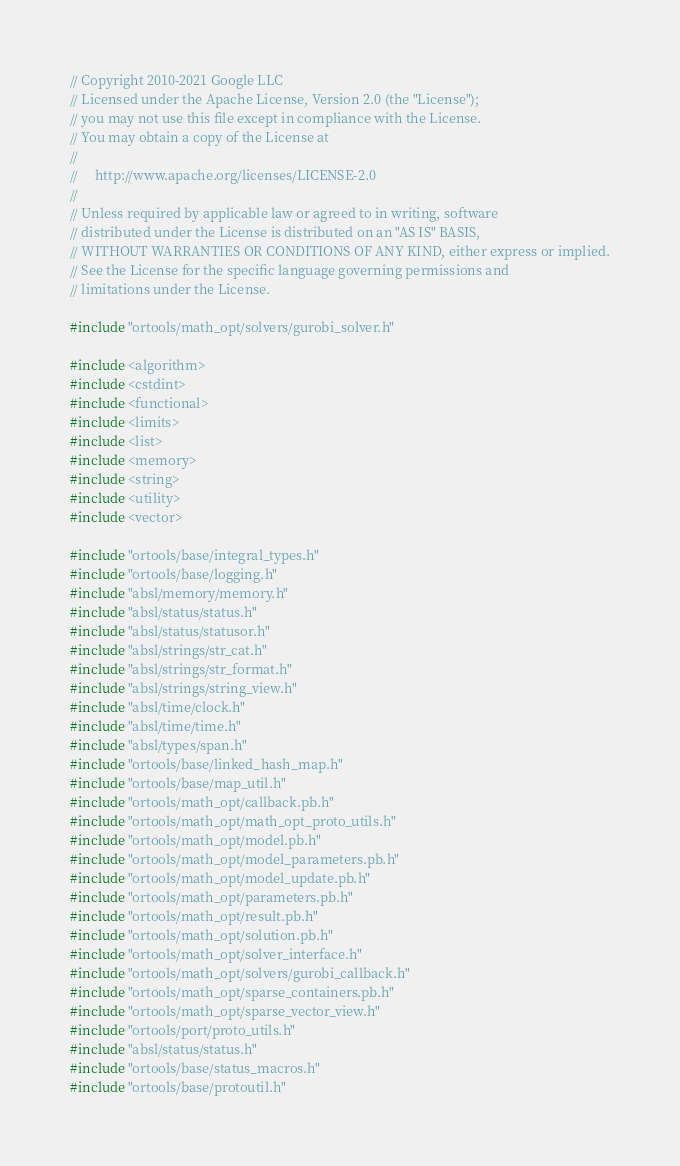Convert code to text. <code><loc_0><loc_0><loc_500><loc_500><_C++_>// Copyright 2010-2021 Google LLC
// Licensed under the Apache License, Version 2.0 (the "License");
// you may not use this file except in compliance with the License.
// You may obtain a copy of the License at
//
//     http://www.apache.org/licenses/LICENSE-2.0
//
// Unless required by applicable law or agreed to in writing, software
// distributed under the License is distributed on an "AS IS" BASIS,
// WITHOUT WARRANTIES OR CONDITIONS OF ANY KIND, either express or implied.
// See the License for the specific language governing permissions and
// limitations under the License.

#include "ortools/math_opt/solvers/gurobi_solver.h"

#include <algorithm>
#include <cstdint>
#include <functional>
#include <limits>
#include <list>
#include <memory>
#include <string>
#include <utility>
#include <vector>

#include "ortools/base/integral_types.h"
#include "ortools/base/logging.h"
#include "absl/memory/memory.h"
#include "absl/status/status.h"
#include "absl/status/statusor.h"
#include "absl/strings/str_cat.h"
#include "absl/strings/str_format.h"
#include "absl/strings/string_view.h"
#include "absl/time/clock.h"
#include "absl/time/time.h"
#include "absl/types/span.h"
#include "ortools/base/linked_hash_map.h"
#include "ortools/base/map_util.h"
#include "ortools/math_opt/callback.pb.h"
#include "ortools/math_opt/math_opt_proto_utils.h"
#include "ortools/math_opt/model.pb.h"
#include "ortools/math_opt/model_parameters.pb.h"
#include "ortools/math_opt/model_update.pb.h"
#include "ortools/math_opt/parameters.pb.h"
#include "ortools/math_opt/result.pb.h"
#include "ortools/math_opt/solution.pb.h"
#include "ortools/math_opt/solver_interface.h"
#include "ortools/math_opt/solvers/gurobi_callback.h"
#include "ortools/math_opt/sparse_containers.pb.h"
#include "ortools/math_opt/sparse_vector_view.h"
#include "ortools/port/proto_utils.h"
#include "absl/status/status.h"
#include "ortools/base/status_macros.h"
#include "ortools/base/protoutil.h"
</code> 